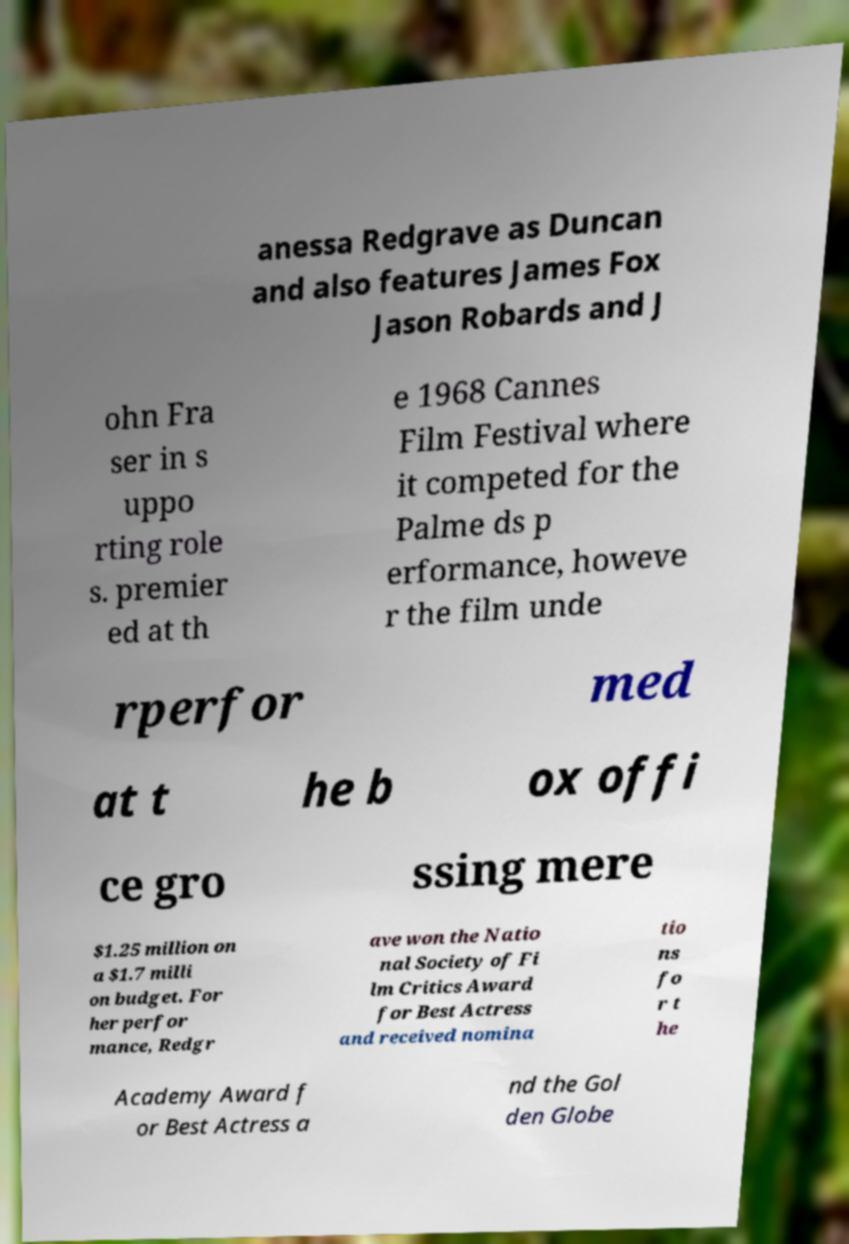What messages or text are displayed in this image? I need them in a readable, typed format. anessa Redgrave as Duncan and also features James Fox Jason Robards and J ohn Fra ser in s uppo rting role s. premier ed at th e 1968 Cannes Film Festival where it competed for the Palme ds p erformance, howeve r the film unde rperfor med at t he b ox offi ce gro ssing mere $1.25 million on a $1.7 milli on budget. For her perfor mance, Redgr ave won the Natio nal Society of Fi lm Critics Award for Best Actress and received nomina tio ns fo r t he Academy Award f or Best Actress a nd the Gol den Globe 